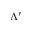Convert formula to latex. <formula><loc_0><loc_0><loc_500><loc_500>\Lambda ^ { \prime }</formula> 